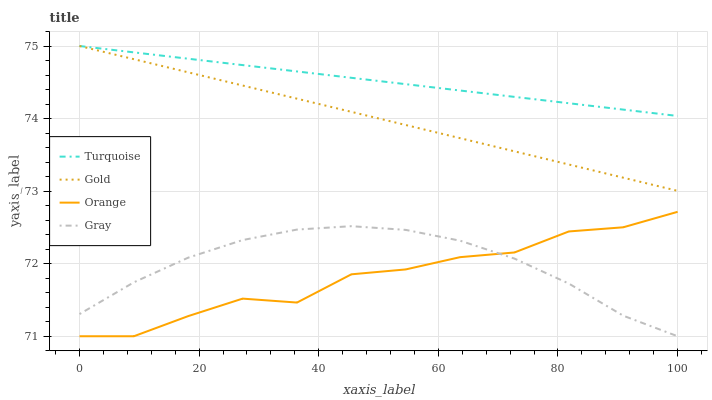Does Orange have the minimum area under the curve?
Answer yes or no. Yes. Does Turquoise have the maximum area under the curve?
Answer yes or no. Yes. Does Gray have the minimum area under the curve?
Answer yes or no. No. Does Gray have the maximum area under the curve?
Answer yes or no. No. Is Gold the smoothest?
Answer yes or no. Yes. Is Orange the roughest?
Answer yes or no. Yes. Is Gray the smoothest?
Answer yes or no. No. Is Gray the roughest?
Answer yes or no. No. Does Orange have the lowest value?
Answer yes or no. Yes. Does Turquoise have the lowest value?
Answer yes or no. No. Does Gold have the highest value?
Answer yes or no. Yes. Does Gray have the highest value?
Answer yes or no. No. Is Gray less than Turquoise?
Answer yes or no. Yes. Is Turquoise greater than Gray?
Answer yes or no. Yes. Does Gold intersect Turquoise?
Answer yes or no. Yes. Is Gold less than Turquoise?
Answer yes or no. No. Is Gold greater than Turquoise?
Answer yes or no. No. Does Gray intersect Turquoise?
Answer yes or no. No. 